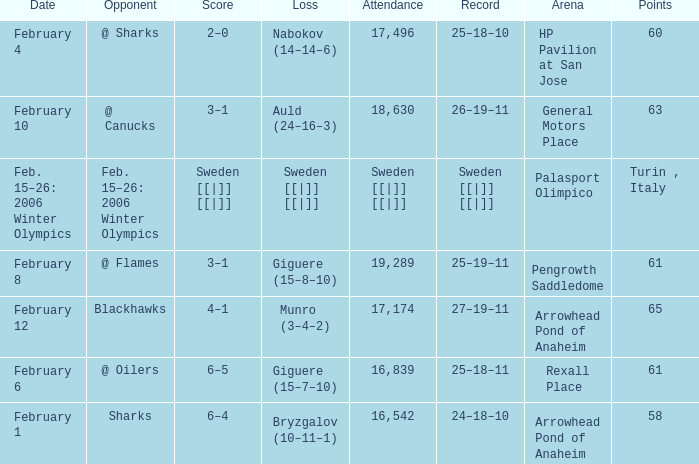What were the points on February 10? 63.0. 